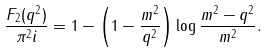<formula> <loc_0><loc_0><loc_500><loc_500>\frac { F _ { 2 } ( q ^ { 2 } ) } { \pi ^ { 2 } i } = 1 - \left ( 1 - \frac { m ^ { 2 } } { q ^ { 2 } } \right ) \log \frac { m ^ { 2 } - q ^ { 2 } } { m ^ { 2 } } .</formula> 